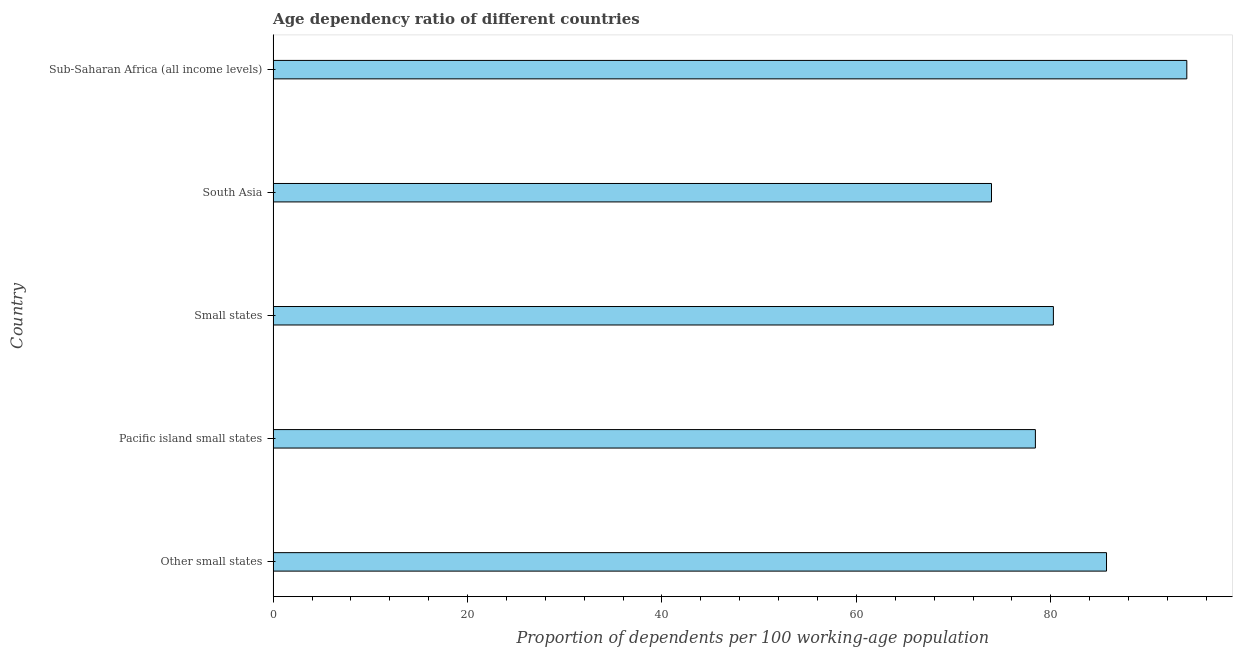Does the graph contain any zero values?
Provide a succinct answer. No. Does the graph contain grids?
Offer a very short reply. No. What is the title of the graph?
Make the answer very short. Age dependency ratio of different countries. What is the label or title of the X-axis?
Your response must be concise. Proportion of dependents per 100 working-age population. What is the label or title of the Y-axis?
Your answer should be very brief. Country. What is the age dependency ratio in Sub-Saharan Africa (all income levels)?
Your response must be concise. 93.99. Across all countries, what is the maximum age dependency ratio?
Give a very brief answer. 93.99. Across all countries, what is the minimum age dependency ratio?
Your response must be concise. 73.9. In which country was the age dependency ratio maximum?
Provide a short and direct response. Sub-Saharan Africa (all income levels). In which country was the age dependency ratio minimum?
Your response must be concise. South Asia. What is the sum of the age dependency ratio?
Provide a succinct answer. 412.31. What is the difference between the age dependency ratio in South Asia and Sub-Saharan Africa (all income levels)?
Your response must be concise. -20.09. What is the average age dependency ratio per country?
Offer a terse response. 82.46. What is the median age dependency ratio?
Give a very brief answer. 80.27. What is the ratio of the age dependency ratio in Other small states to that in South Asia?
Make the answer very short. 1.16. Is the age dependency ratio in Other small states less than that in Sub-Saharan Africa (all income levels)?
Offer a terse response. Yes. What is the difference between the highest and the second highest age dependency ratio?
Provide a succinct answer. 8.26. Is the sum of the age dependency ratio in Small states and South Asia greater than the maximum age dependency ratio across all countries?
Your answer should be very brief. Yes. What is the difference between the highest and the lowest age dependency ratio?
Offer a terse response. 20.09. In how many countries, is the age dependency ratio greater than the average age dependency ratio taken over all countries?
Give a very brief answer. 2. Are all the bars in the graph horizontal?
Offer a terse response. Yes. How many countries are there in the graph?
Make the answer very short. 5. What is the difference between two consecutive major ticks on the X-axis?
Make the answer very short. 20. What is the Proportion of dependents per 100 working-age population in Other small states?
Offer a terse response. 85.73. What is the Proportion of dependents per 100 working-age population of Pacific island small states?
Give a very brief answer. 78.42. What is the Proportion of dependents per 100 working-age population in Small states?
Ensure brevity in your answer.  80.27. What is the Proportion of dependents per 100 working-age population in South Asia?
Provide a short and direct response. 73.9. What is the Proportion of dependents per 100 working-age population of Sub-Saharan Africa (all income levels)?
Give a very brief answer. 93.99. What is the difference between the Proportion of dependents per 100 working-age population in Other small states and Pacific island small states?
Give a very brief answer. 7.32. What is the difference between the Proportion of dependents per 100 working-age population in Other small states and Small states?
Offer a very short reply. 5.46. What is the difference between the Proportion of dependents per 100 working-age population in Other small states and South Asia?
Keep it short and to the point. 11.83. What is the difference between the Proportion of dependents per 100 working-age population in Other small states and Sub-Saharan Africa (all income levels)?
Ensure brevity in your answer.  -8.26. What is the difference between the Proportion of dependents per 100 working-age population in Pacific island small states and Small states?
Ensure brevity in your answer.  -1.85. What is the difference between the Proportion of dependents per 100 working-age population in Pacific island small states and South Asia?
Make the answer very short. 4.52. What is the difference between the Proportion of dependents per 100 working-age population in Pacific island small states and Sub-Saharan Africa (all income levels)?
Offer a terse response. -15.58. What is the difference between the Proportion of dependents per 100 working-age population in Small states and South Asia?
Your answer should be very brief. 6.37. What is the difference between the Proportion of dependents per 100 working-age population in Small states and Sub-Saharan Africa (all income levels)?
Your answer should be very brief. -13.72. What is the difference between the Proportion of dependents per 100 working-age population in South Asia and Sub-Saharan Africa (all income levels)?
Make the answer very short. -20.09. What is the ratio of the Proportion of dependents per 100 working-age population in Other small states to that in Pacific island small states?
Provide a succinct answer. 1.09. What is the ratio of the Proportion of dependents per 100 working-age population in Other small states to that in Small states?
Make the answer very short. 1.07. What is the ratio of the Proportion of dependents per 100 working-age population in Other small states to that in South Asia?
Give a very brief answer. 1.16. What is the ratio of the Proportion of dependents per 100 working-age population in Other small states to that in Sub-Saharan Africa (all income levels)?
Provide a short and direct response. 0.91. What is the ratio of the Proportion of dependents per 100 working-age population in Pacific island small states to that in Small states?
Ensure brevity in your answer.  0.98. What is the ratio of the Proportion of dependents per 100 working-age population in Pacific island small states to that in South Asia?
Provide a succinct answer. 1.06. What is the ratio of the Proportion of dependents per 100 working-age population in Pacific island small states to that in Sub-Saharan Africa (all income levels)?
Your answer should be compact. 0.83. What is the ratio of the Proportion of dependents per 100 working-age population in Small states to that in South Asia?
Provide a succinct answer. 1.09. What is the ratio of the Proportion of dependents per 100 working-age population in Small states to that in Sub-Saharan Africa (all income levels)?
Provide a succinct answer. 0.85. What is the ratio of the Proportion of dependents per 100 working-age population in South Asia to that in Sub-Saharan Africa (all income levels)?
Keep it short and to the point. 0.79. 